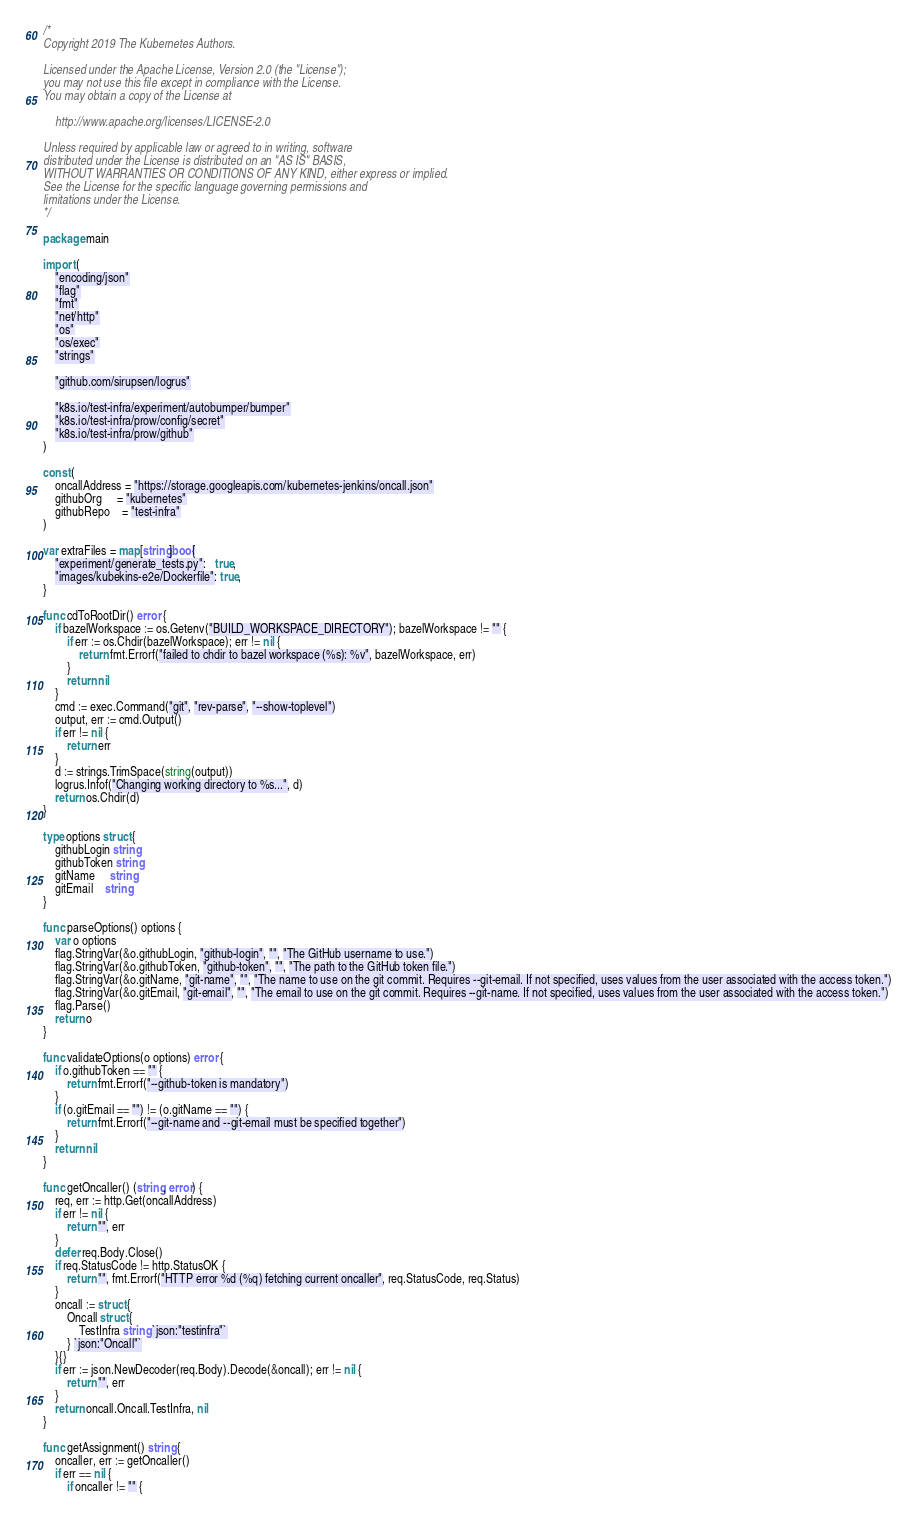<code> <loc_0><loc_0><loc_500><loc_500><_Go_>/*
Copyright 2019 The Kubernetes Authors.

Licensed under the Apache License, Version 2.0 (the "License");
you may not use this file except in compliance with the License.
You may obtain a copy of the License at

    http://www.apache.org/licenses/LICENSE-2.0

Unless required by applicable law or agreed to in writing, software
distributed under the License is distributed on an "AS IS" BASIS,
WITHOUT WARRANTIES OR CONDITIONS OF ANY KIND, either express or implied.
See the License for the specific language governing permissions and
limitations under the License.
*/

package main

import (
	"encoding/json"
	"flag"
	"fmt"
	"net/http"
	"os"
	"os/exec"
	"strings"

	"github.com/sirupsen/logrus"

	"k8s.io/test-infra/experiment/autobumper/bumper"
	"k8s.io/test-infra/prow/config/secret"
	"k8s.io/test-infra/prow/github"
)

const (
	oncallAddress = "https://storage.googleapis.com/kubernetes-jenkins/oncall.json"
	githubOrg     = "kubernetes"
	githubRepo    = "test-infra"
)

var extraFiles = map[string]bool{
	"experiment/generate_tests.py":   true,
	"images/kubekins-e2e/Dockerfile": true,
}

func cdToRootDir() error {
	if bazelWorkspace := os.Getenv("BUILD_WORKSPACE_DIRECTORY"); bazelWorkspace != "" {
		if err := os.Chdir(bazelWorkspace); err != nil {
			return fmt.Errorf("failed to chdir to bazel workspace (%s): %v", bazelWorkspace, err)
		}
		return nil
	}
	cmd := exec.Command("git", "rev-parse", "--show-toplevel")
	output, err := cmd.Output()
	if err != nil {
		return err
	}
	d := strings.TrimSpace(string(output))
	logrus.Infof("Changing working directory to %s...", d)
	return os.Chdir(d)
}

type options struct {
	githubLogin string
	githubToken string
	gitName     string
	gitEmail    string
}

func parseOptions() options {
	var o options
	flag.StringVar(&o.githubLogin, "github-login", "", "The GitHub username to use.")
	flag.StringVar(&o.githubToken, "github-token", "", "The path to the GitHub token file.")
	flag.StringVar(&o.gitName, "git-name", "", "The name to use on the git commit. Requires --git-email. If not specified, uses values from the user associated with the access token.")
	flag.StringVar(&o.gitEmail, "git-email", "", "The email to use on the git commit. Requires --git-name. If not specified, uses values from the user associated with the access token.")
	flag.Parse()
	return o
}

func validateOptions(o options) error {
	if o.githubToken == "" {
		return fmt.Errorf("--github-token is mandatory")
	}
	if (o.gitEmail == "") != (o.gitName == "") {
		return fmt.Errorf("--git-name and --git-email must be specified together")
	}
	return nil
}

func getOncaller() (string, error) {
	req, err := http.Get(oncallAddress)
	if err != nil {
		return "", err
	}
	defer req.Body.Close()
	if req.StatusCode != http.StatusOK {
		return "", fmt.Errorf("HTTP error %d (%q) fetching current oncaller", req.StatusCode, req.Status)
	}
	oncall := struct {
		Oncall struct {
			TestInfra string `json:"testinfra"`
		} `json:"Oncall"`
	}{}
	if err := json.NewDecoder(req.Body).Decode(&oncall); err != nil {
		return "", err
	}
	return oncall.Oncall.TestInfra, nil
}

func getAssignment() string {
	oncaller, err := getOncaller()
	if err == nil {
		if oncaller != "" {</code> 